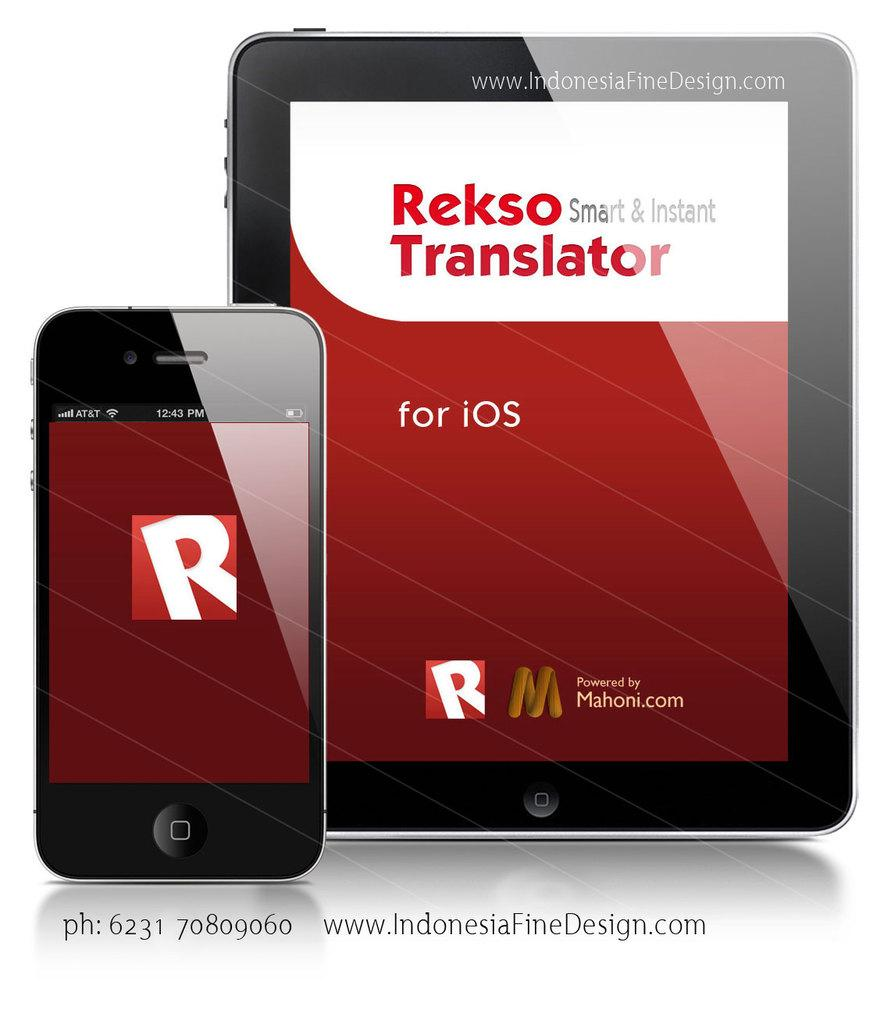Provide a one-sentence caption for the provided image. Rekso Smart and Instant Translator is shown on a smartphone and tablet. 